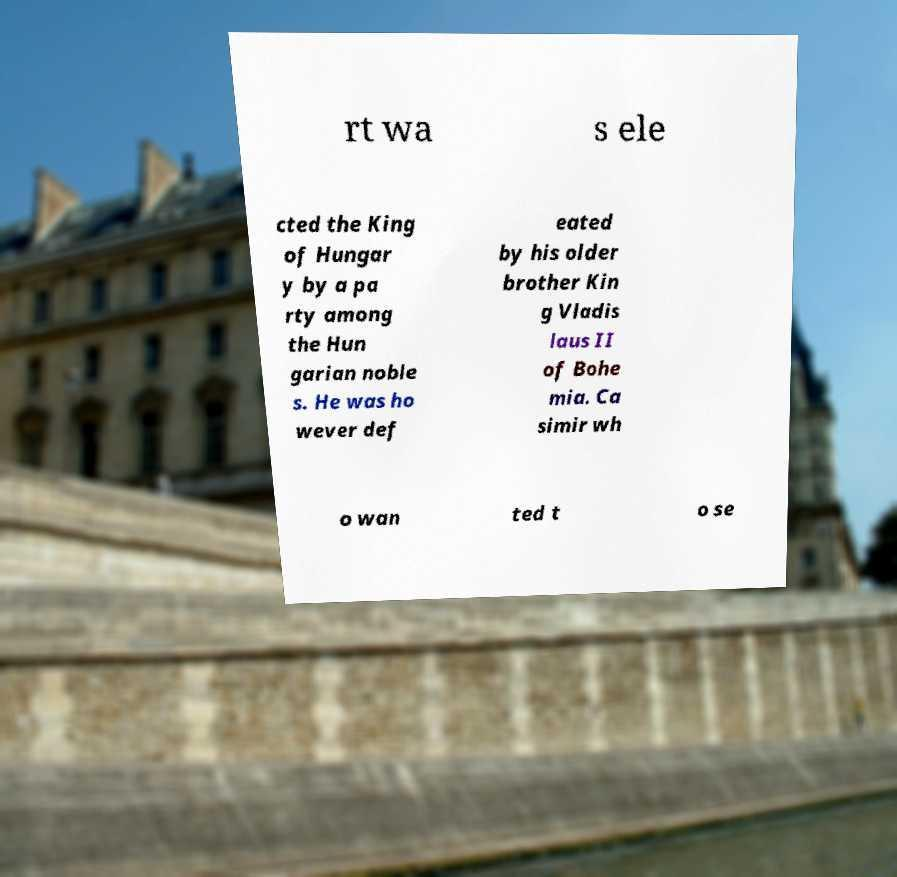Could you assist in decoding the text presented in this image and type it out clearly? rt wa s ele cted the King of Hungar y by a pa rty among the Hun garian noble s. He was ho wever def eated by his older brother Kin g Vladis laus II of Bohe mia. Ca simir wh o wan ted t o se 